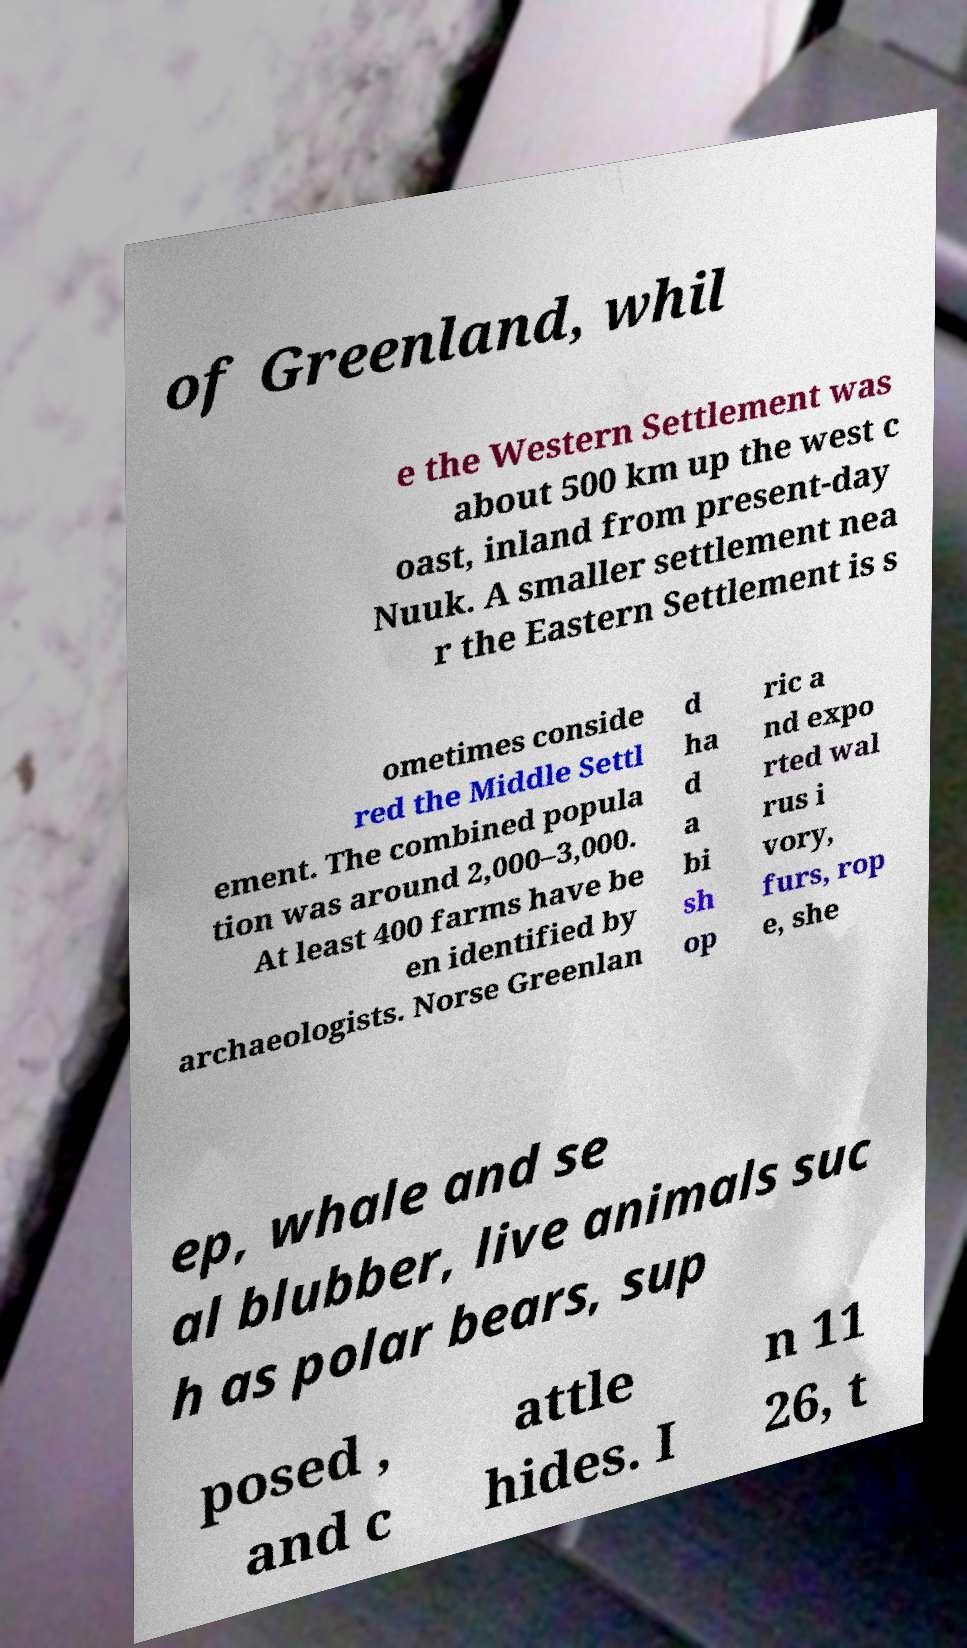There's text embedded in this image that I need extracted. Can you transcribe it verbatim? of Greenland, whil e the Western Settlement was about 500 km up the west c oast, inland from present-day Nuuk. A smaller settlement nea r the Eastern Settlement is s ometimes conside red the Middle Settl ement. The combined popula tion was around 2,000–3,000. At least 400 farms have be en identified by archaeologists. Norse Greenlan d ha d a bi sh op ric a nd expo rted wal rus i vory, furs, rop e, she ep, whale and se al blubber, live animals suc h as polar bears, sup posed , and c attle hides. I n 11 26, t 